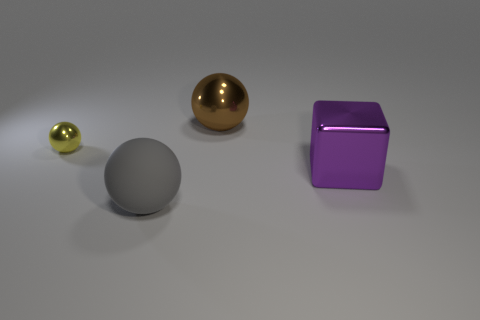Add 2 small brown rubber blocks. How many objects exist? 6 Subtract all cubes. How many objects are left? 3 Subtract all gray rubber balls. How many balls are left? 2 Subtract all large rubber balls. Subtract all blocks. How many objects are left? 2 Add 3 gray matte objects. How many gray matte objects are left? 4 Add 1 yellow cylinders. How many yellow cylinders exist? 1 Subtract all yellow spheres. How many spheres are left? 2 Subtract 0 red spheres. How many objects are left? 4 Subtract 2 balls. How many balls are left? 1 Subtract all blue blocks. Subtract all cyan cylinders. How many blocks are left? 1 